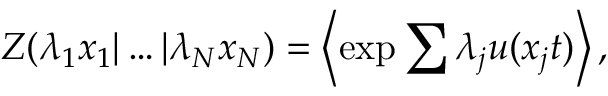Convert formula to latex. <formula><loc_0><loc_0><loc_500><loc_500>Z ( \lambda _ { 1 } x _ { 1 } | \dots | \lambda _ { N } x _ { N } ) = \left \langle \exp { \sum { \lambda _ { j } u ( x _ { j } t ) } } \right \rangle ,</formula> 